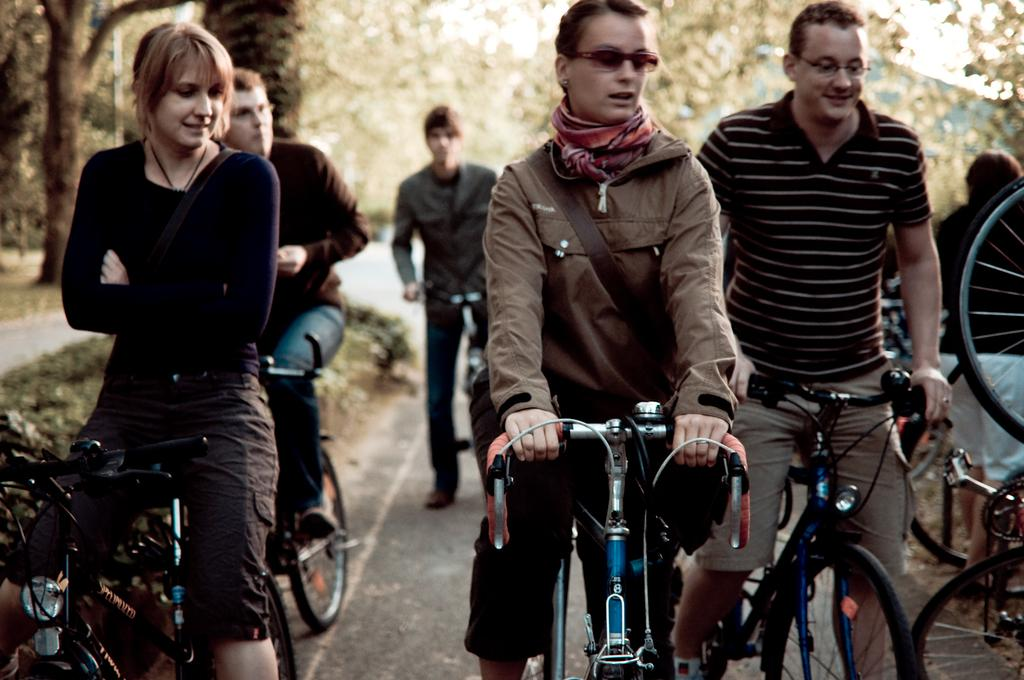Who or what can be seen in the image? There are people in the image. What are the people doing in the image? The people are sitting on bicycles. Where are the bicycles located in the image? The bicycles are parked on the road. What type of skin condition can be seen on the writer in the image? There is no writer present in the image, and therefore no skin condition can be observed. 